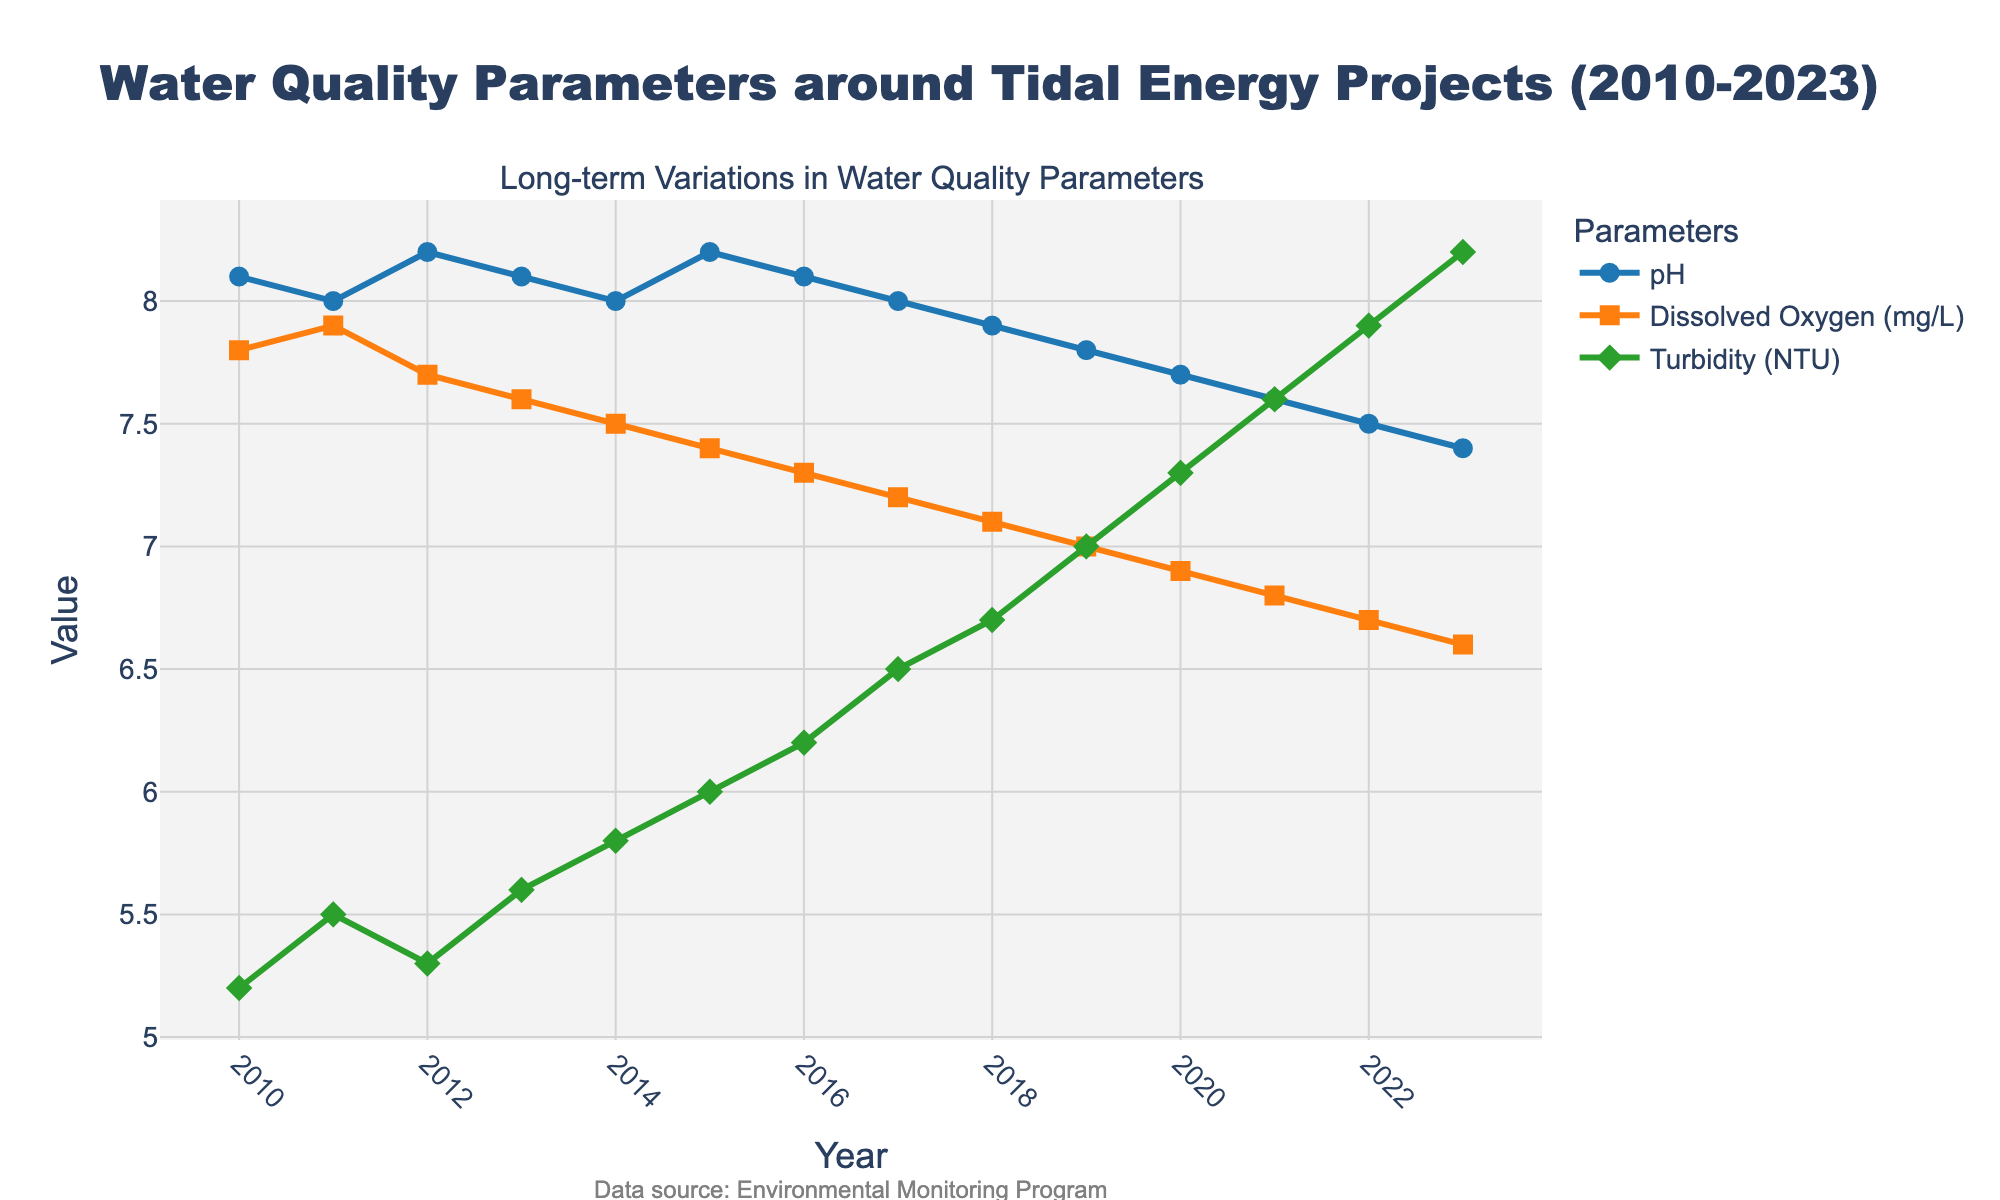What's the trend in pH levels from 2010 to 2023? The pH levels have been gradually decreasing from 8.1 in 2010 to 7.4 in 2023, indicating a trend towards increasing acidity.
Answer: Decreasing In which year did the Dissolved Oxygen levels start dropping below 7.8 mg/L? By looking at the Dissolved Oxygen trend, it drops below 7.8 mg/L starting in 2012.
Answer: 2012 Which parameter shows a consistent increase over the years? By examining the trend lines, Turbidity (NTU) consistently increases from 2010 to 2023.
Answer: Turbidity What is the difference in pH levels between 2010 and 2023? The pH level in 2010 is 8.1 and in 2023 is 7.4. The difference is 8.1 - 7.4.
Answer: 0.7 How does the trend of Dissolved Oxygen compare to Turbidity over the years? Dissolved Oxygen decreases consistently from 7.8 mg/L in 2010 to 6.6 mg/L in 2023, whereas Turbidity increases from 5.2 NTU in 2010 to 8.2 NTU in 2023.
Answer: Dissolved Oxygen decreases, Turbidity increases Did Turbidity reach 8 NTU before 2023? Turbidity reaches 8.2 NTU in 2023. In the previous year, 2022, it is at 7.9 NTU.
Answer: No Which year had the lowest pH level and what was it? The year 2023 had the lowest pH level, which was 7.4.
Answer: 2023, 7.4 How much did the Dissolved Oxygen levels decline between 2010 and 2020? Dissolved Oxygen levels declined from 7.8 mg/L in 2010 to 6.9 mg/L in 2020. The decline is 7.8 - 6.9.
Answer: 0.9 mg/L What was the average pH level over the years 2010-2015? pH levels from 2010 to 2015 are 8.1, 8.0, 8.2, 8.1, 8.0, 8.2. The average pH is (8.1 + 8.0 + 8.2 + 8.1 + 8.0 + 8.2) / 6.
Answer: 8.1 In 2019, which parameter is closer to its respective 2023 value, pH or Dissolved Oxygen? In 2019, the pH is 7.8, and in 2023 it is 7.4, a difference of 0.4. Dissolved Oxygen in 2019 is 7.0 mg/L, and in 2023 it is 6.6 mg/L, a difference of 0.4. Both parameters are equally close to their 2023 values.
Answer: Both 